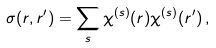Convert formula to latex. <formula><loc_0><loc_0><loc_500><loc_500>\sigma ( { r } , { r } ^ { \prime } ) = \sum _ { s } \chi ^ { ( s ) } ( { r } ) \chi ^ { ( s ) } ( { r } ^ { \prime } ) \, ,</formula> 